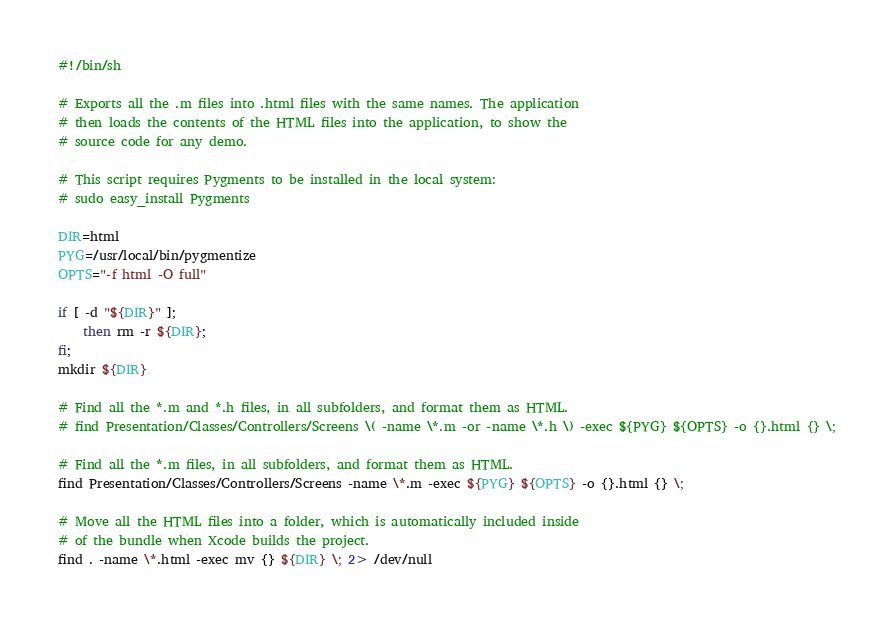Convert code to text. <code><loc_0><loc_0><loc_500><loc_500><_Bash_>#!/bin/sh

# Exports all the .m files into .html files with the same names. The application
# then loads the contents of the HTML files into the application, to show the
# source code for any demo.

# This script requires Pygments to be installed in the local system:
# sudo easy_install Pygments

DIR=html
PYG=/usr/local/bin/pygmentize
OPTS="-f html -O full"

if [ -d "${DIR}" ];
    then rm -r ${DIR};
fi;
mkdir ${DIR}

# Find all the *.m and *.h files, in all subfolders, and format them as HTML.
# find Presentation/Classes/Controllers/Screens \( -name \*.m -or -name \*.h \) -exec ${PYG} ${OPTS} -o {}.html {} \;

# Find all the *.m files, in all subfolders, and format them as HTML.
find Presentation/Classes/Controllers/Screens -name \*.m -exec ${PYG} ${OPTS} -o {}.html {} \;

# Move all the HTML files into a folder, which is automatically included inside
# of the bundle when Xcode builds the project.
find . -name \*.html -exec mv {} ${DIR} \; 2> /dev/null
</code> 